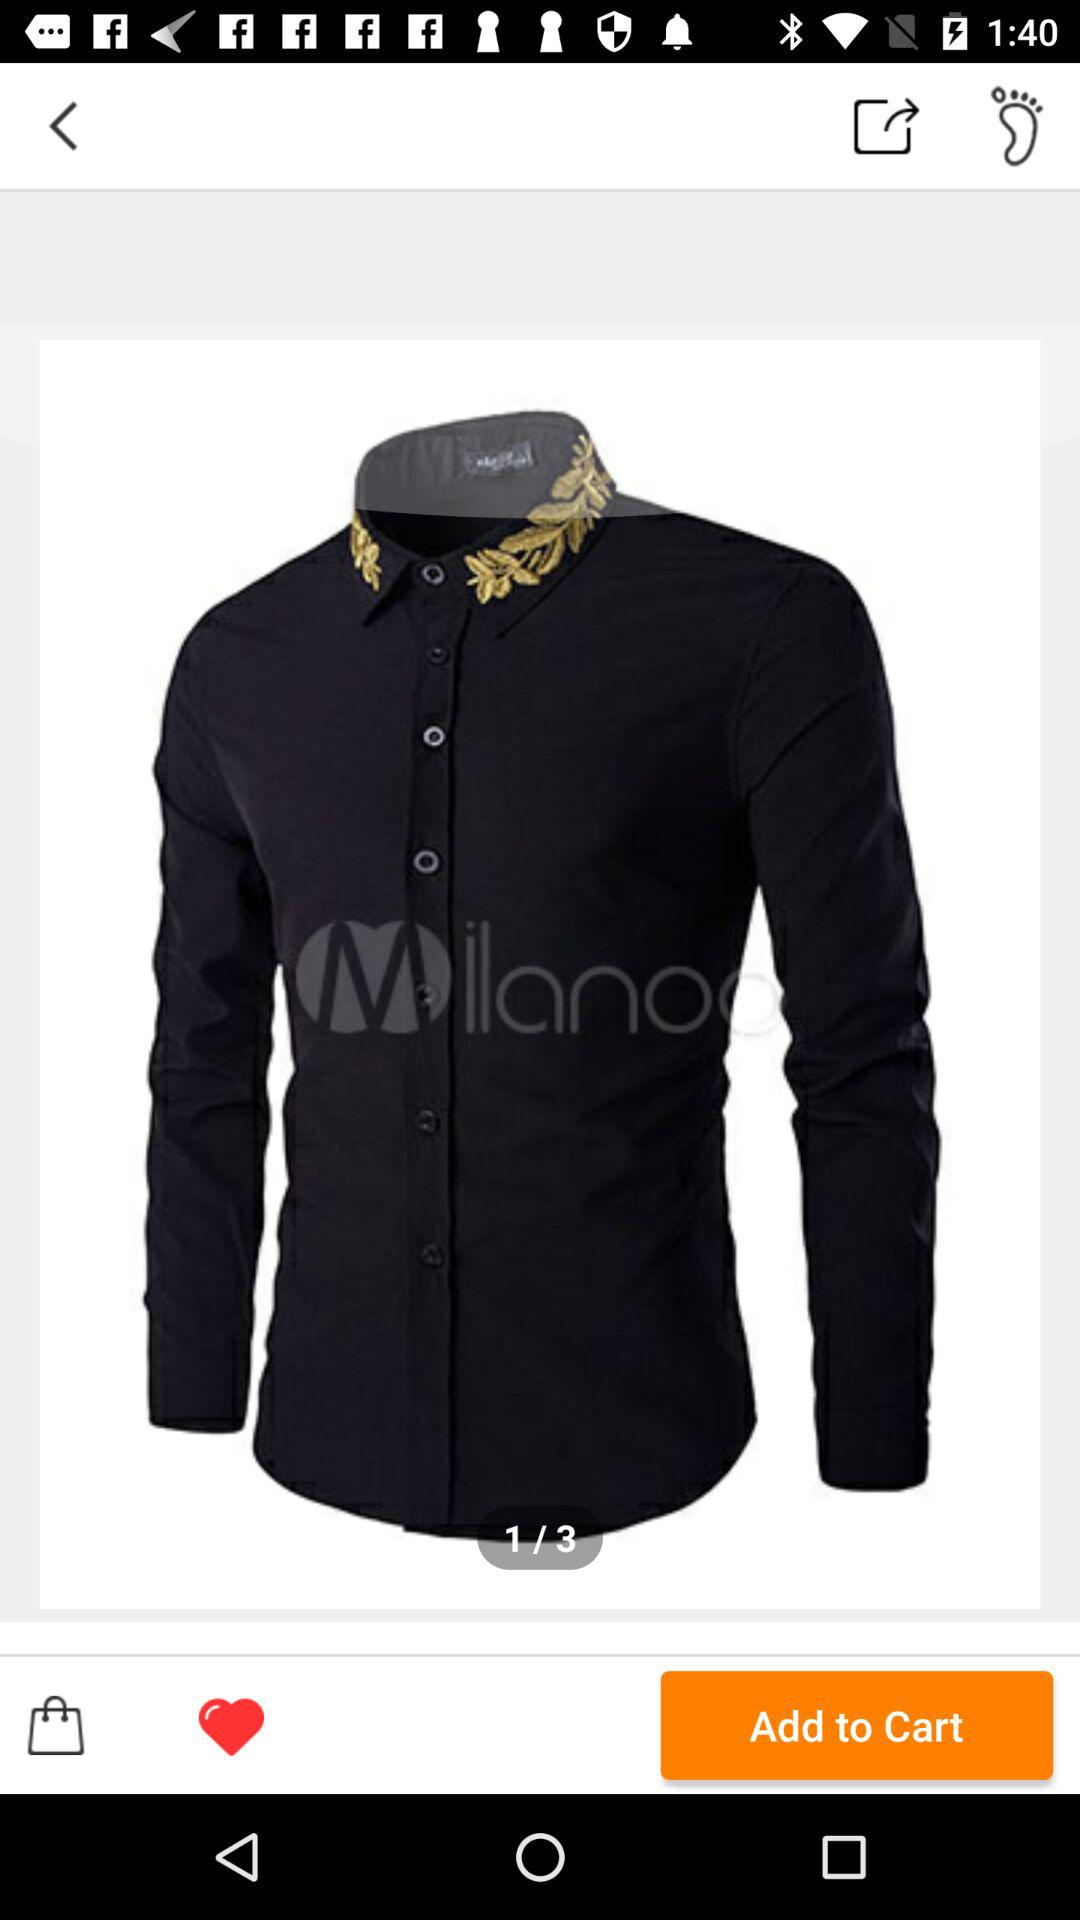How many total photos are there? There are a total of 3 photos. 